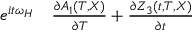Convert formula to latex. <formula><loc_0><loc_0><loc_500><loc_500>\begin{array} { r l } { e ^ { i t \omega _ { H } } } & \frac { \partial A _ { 1 } ( T , X ) } { \partial T } + \frac { \partial Z _ { 3 } ( t , T , X ) } { \partial t } } \end{array}</formula> 